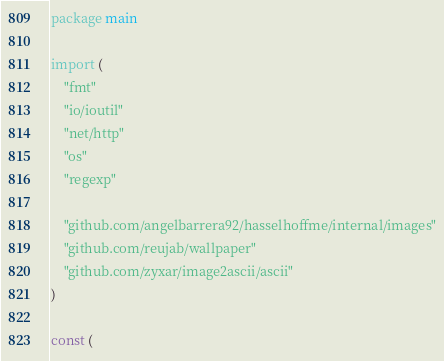<code> <loc_0><loc_0><loc_500><loc_500><_Go_>package main

import (
	"fmt"
	"io/ioutil"
	"net/http"
	"os"
	"regexp"

	"github.com/angelbarrera92/hasselhoffme/internal/images"
	"github.com/reujab/wallpaper"
	"github.com/zyxar/image2ascii/ascii"
)

const (</code> 